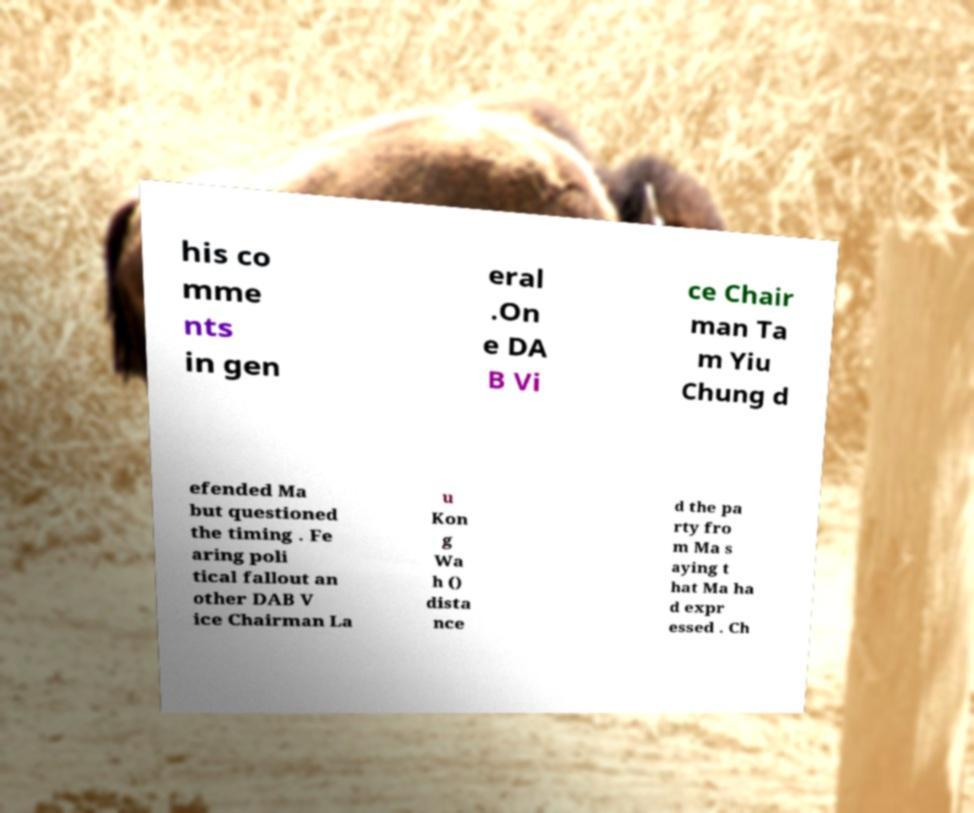Please identify and transcribe the text found in this image. his co mme nts in gen eral .On e DA B Vi ce Chair man Ta m Yiu Chung d efended Ma but questioned the timing . Fe aring poli tical fallout an other DAB V ice Chairman La u Kon g Wa h () dista nce d the pa rty fro m Ma s aying t hat Ma ha d expr essed . Ch 